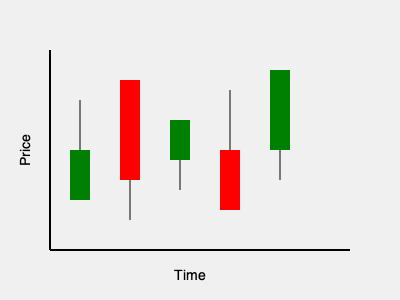Based on the candlestick chart pattern shown, what trading signal does this formation typically indicate? To interpret this candlestick chart pattern:

1. Observe the overall trend: The chart shows a series of five candlesticks moving from left to right.

2. Analyze individual candlesticks:
   - Green candlesticks indicate closing prices higher than opening prices (bullish).
   - Red candlesticks indicate closing prices lower than opening prices (bearish).

3. Identify the pattern:
   - The first candlestick is green (bullish).
   - The second candlestick is red and longer (strongly bearish).
   - The third candlestick is small and green (slight bullish movement).
   - The fourth candlestick is red (bearish).
   - The final candlestick is green and shows a significant price increase (strongly bullish).

4. Recognize the formation:
   This pattern resembles a "Bullish Engulfing" pattern, particularly focusing on the last two candlesticks.

5. Interpret the signal:
   - The last green candlestick completely engulfs the previous red candlestick.
   - This suggests a potential reversal from a downtrend to an uptrend.
   - It indicates that buyers have overwhelmed sellers, potentially signaling the end of a bearish trend.

Given this analysis, the pattern typically indicates a bullish reversal signal, suggesting a potential upward price movement in the near future.
Answer: Bullish reversal 